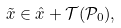<formula> <loc_0><loc_0><loc_500><loc_500>\tilde { x } \in \hat { x } + \mathcal { T } ( \mathcal { P } _ { 0 } ) ,</formula> 